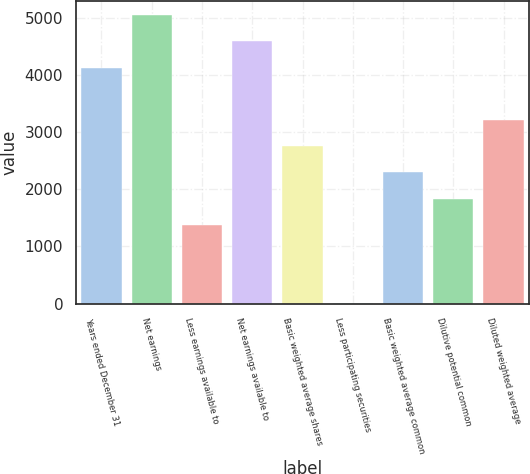Convert chart. <chart><loc_0><loc_0><loc_500><loc_500><bar_chart><fcel>Years ended December 31<fcel>Net earnings<fcel>Less earnings available to<fcel>Net earnings available to<fcel>Basic weighted average shares<fcel>Less participating securities<fcel>Basic weighted average common<fcel>Dilutive potential common<fcel>Diluted weighted average<nl><fcel>4126.69<fcel>5043.31<fcel>1376.83<fcel>4585<fcel>2751.76<fcel>1.9<fcel>2293.45<fcel>1835.14<fcel>3210.07<nl></chart> 